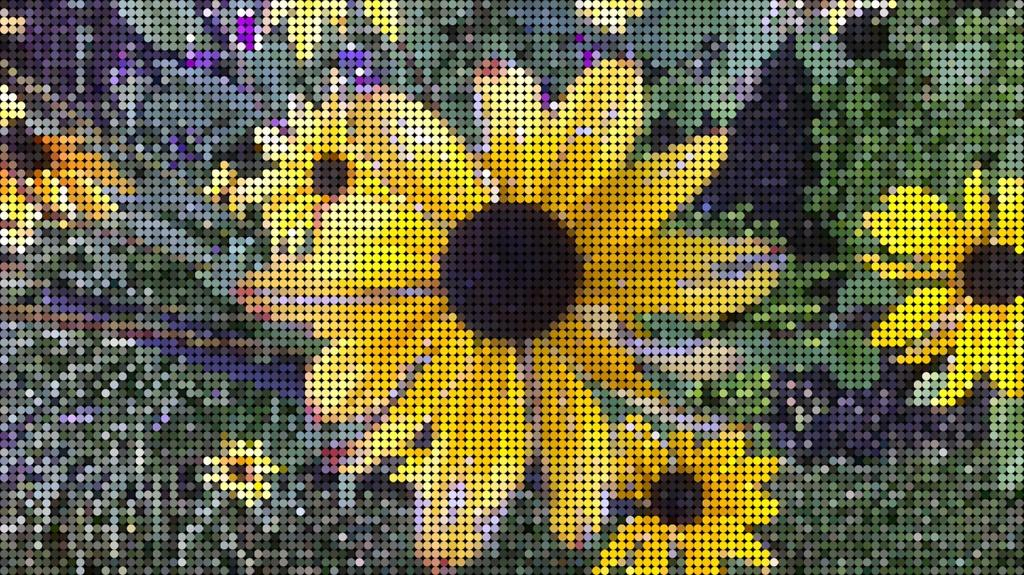What type of flowers are in the image? There are sunflowers in the image. What colors are the sunflowers? The sunflowers are in yellow and black color. What can be seen in the background of the image? The background of the image is in a different color. What type of juice is being squeezed from the sunflowers in the image? There is no juice being squeezed from the sunflowers in the image, as they are flowers and not fruits. Can you see any hands holding the sunflowers in the image? There is no mention of hands or anyone holding the sunflowers in the image. 